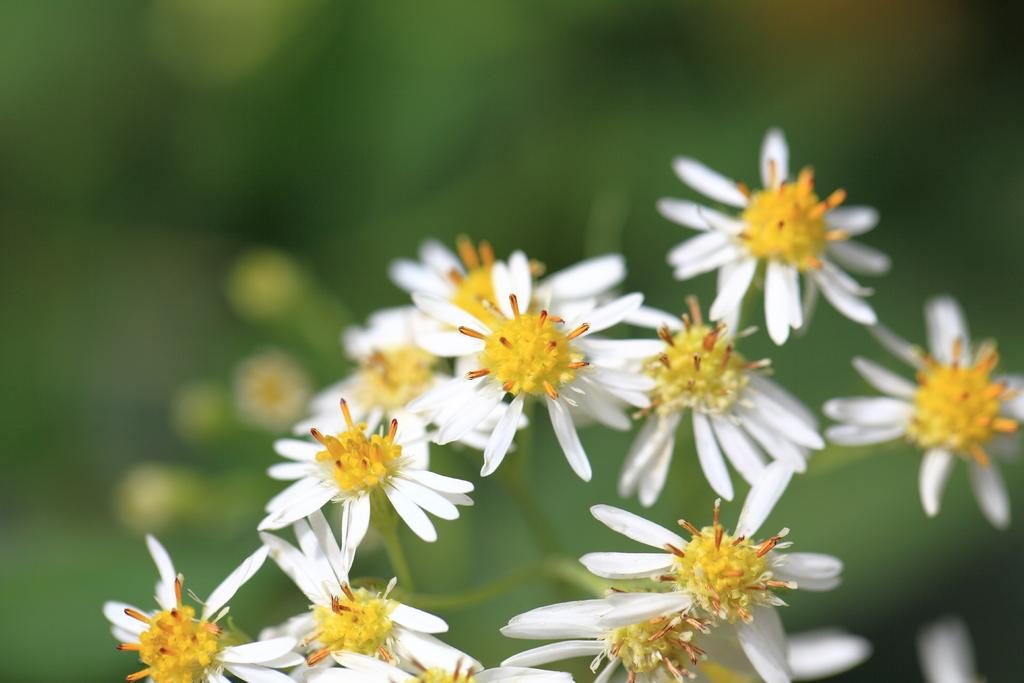What type of plants can be seen in the image? There are flowers in the image. What color is the background of the image? The background of the image is green in color. What type of apples are being served for dinner in the image? There are no apples or dinner present in the image; it only features flowers and a green background. 